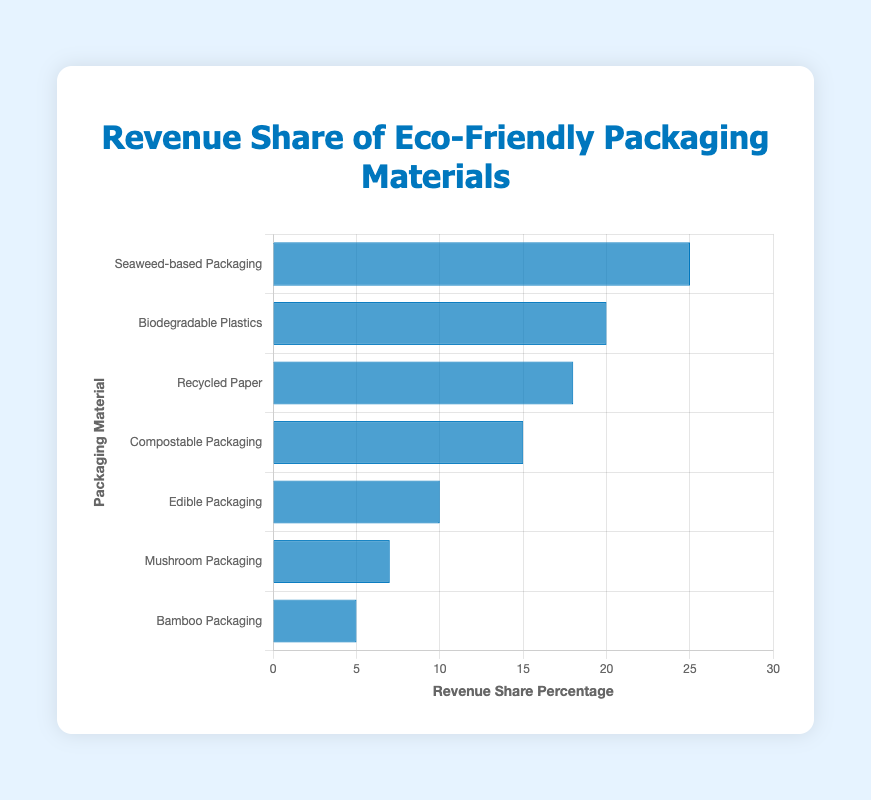What material has the highest revenue share? The material with the highest bar represents the highest revenue share. Seaweed-based Packaging has the highest bar at 25%.
Answer: Seaweed-based Packaging How much higher is the revenue share of Seaweed-based Packaging compared to Bamboo Packaging? Subtract the revenue share of Bamboo Packaging (5%) from Seaweed-based Packaging (25%). 25% - 5% = 20%.
Answer: 20% Which material has the smallest revenue share? The material with the shortest bar represents the smallest revenue share. Bamboo Packaging has the smallest bar at 5%.
Answer: Bamboo Packaging What is the total revenue share percentage of Recycled Paper and Compostable Packaging combined? Add the revenue shares of Recycled Paper (18%) and Compostable Packaging (15%). 18% + 15% = 33%.
Answer: 33% Is the revenue share of Biodegradable Plastics greater than or equal to Mushroom Packaging and Edible Packaging combined? Combine the revenue shares of Mushroom Packaging (7%) and Edible Packaging (10%). 7% + 10% = 17%. Compare this with Biodegradable Plastics (20%). 20% > 17%.
Answer: Yes What is the average revenue share of all the materials? Sum all revenue shares and divide by the number of materials: (25% + 20% + 18% + 15% + 10% + 7% + 5%) / 7 = 100% / 7 ≈ 14.29%.
Answer: 14.29% Between Seaweed-based Packaging and Compostable Packaging, which has a higher revenue share and by how much? Compare the revenue shares of Seaweed-based Packaging (25%) and Compostable Packaging (15%). Subtract the smaller from the larger. 25% - 15% = 10%.
Answer: Seaweed-based Packaging by 10% What is the range of revenue shares among the materials? Find the difference between the highest revenue share (Seaweed-based Packaging, 25%) and the lowest (Bamboo Packaging, 5%). 25% - 5% = 20%.
Answer: 20% Is the combined revenue share of Biodegradable Plastics and Recycled Paper greater than Seaweed-based Packaging? Combine the revenue shares of Biodegradable Plastics (20%) and Recycled Paper (18%). 20% + 18% = 38%. Compare this with Seaweed-based Packaging (25%). 38% > 25%.
Answer: Yes What percentage of the total revenue share is accounted for by materials other than Seaweed-based Packaging and Biodegradable Plastics? Sum the revenue shares of other materials and subtract the shares of the two mentioned: 100% - (25% + 20%) = 100% - 45% = 55%.
Answer: 55% 